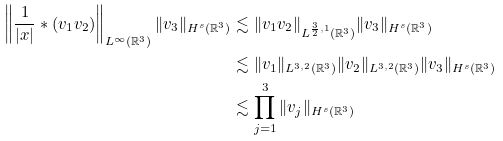<formula> <loc_0><loc_0><loc_500><loc_500>\left \| \frac { 1 } { | x | } * ( v _ { 1 } v _ { 2 } ) \right \| _ { L ^ { \infty } ( \mathbb { R } ^ { 3 } ) } \| v _ { 3 } \| _ { H ^ { s } ( \mathbb { R } ^ { 3 } ) } & \lesssim \| v _ { 1 } v _ { 2 } \| _ { L ^ { \frac { 3 } { 2 } , 1 } ( \mathbb { R } ^ { 3 } ) } \| v _ { 3 } \| _ { H ^ { s } ( \mathbb { R } ^ { 3 } ) } \\ & \lesssim \| v _ { 1 } \| _ { L ^ { 3 , 2 } ( \mathbb { R } ^ { 3 } ) } \| v _ { 2 } \| _ { L ^ { 3 , 2 } ( \mathbb { R } ^ { 3 } ) } \| v _ { 3 } \| _ { H ^ { s } ( \mathbb { R } ^ { 3 } ) } \\ & \lesssim \prod _ { j = 1 } ^ { 3 } \| v _ { j } \| _ { H ^ { s } ( \mathbb { R } ^ { 3 } ) }</formula> 